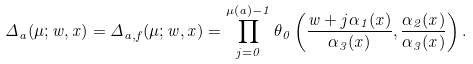Convert formula to latex. <formula><loc_0><loc_0><loc_500><loc_500>\Delta _ { a } ( \mu ; w , x ) = \Delta _ { a , f } ( \mu ; w , x ) = \prod _ { j = 0 } ^ { \mu ( a ) - 1 } \theta _ { 0 } \left ( \frac { w + j \alpha _ { 1 } ( x ) } { \alpha _ { 3 } ( x ) } , \frac { \alpha _ { 2 } ( x ) } { \alpha _ { 3 } ( x ) } \right ) .</formula> 